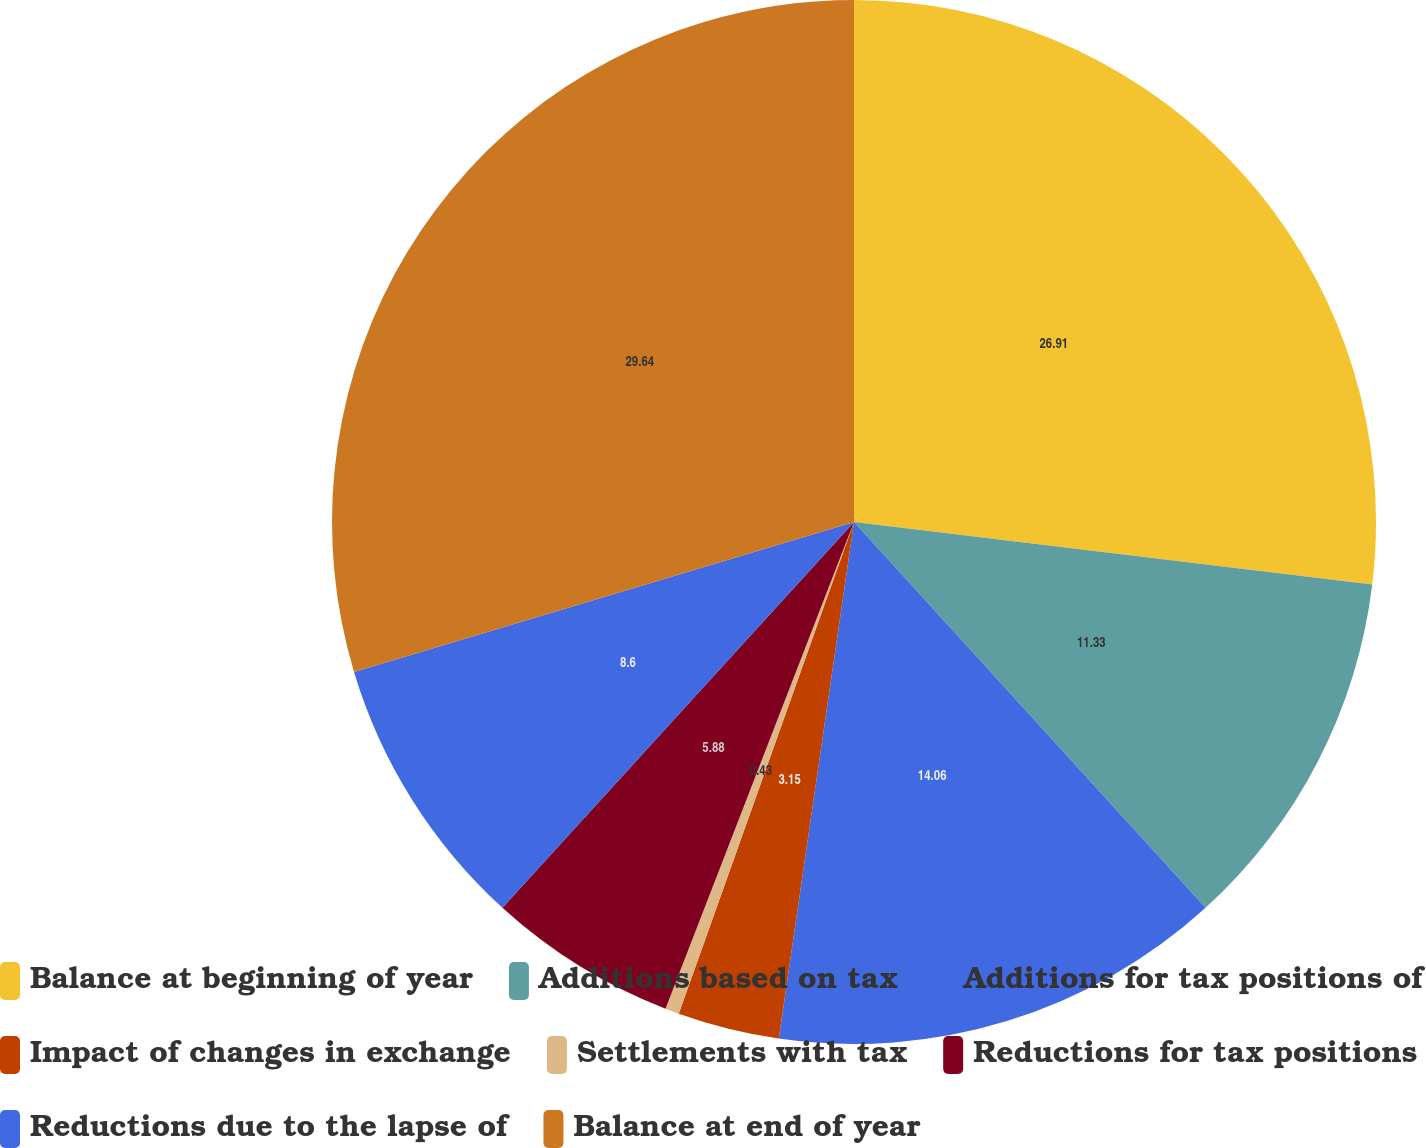<chart> <loc_0><loc_0><loc_500><loc_500><pie_chart><fcel>Balance at beginning of year<fcel>Additions based on tax<fcel>Additions for tax positions of<fcel>Impact of changes in exchange<fcel>Settlements with tax<fcel>Reductions for tax positions<fcel>Reductions due to the lapse of<fcel>Balance at end of year<nl><fcel>26.91%<fcel>11.33%<fcel>14.06%<fcel>3.15%<fcel>0.43%<fcel>5.88%<fcel>8.6%<fcel>29.64%<nl></chart> 